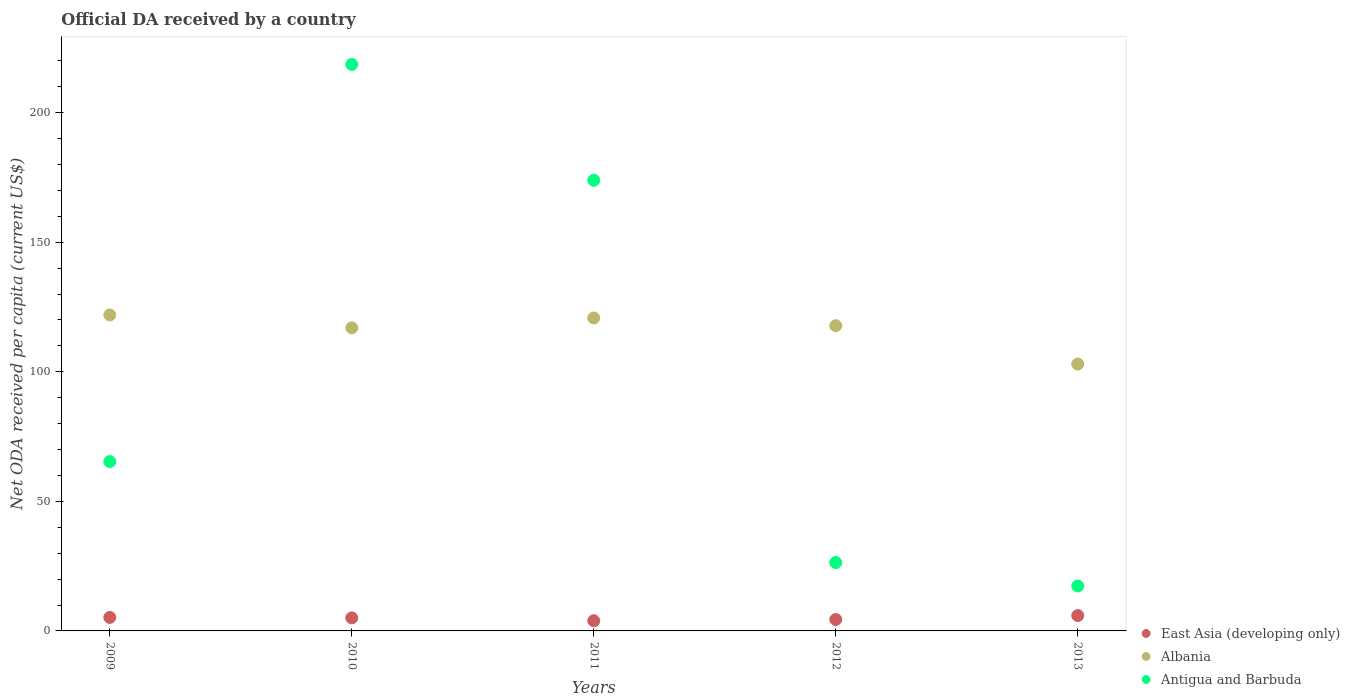Is the number of dotlines equal to the number of legend labels?
Offer a terse response. Yes. What is the ODA received in in East Asia (developing only) in 2013?
Your answer should be very brief. 5.92. Across all years, what is the maximum ODA received in in Antigua and Barbuda?
Ensure brevity in your answer.  218.61. Across all years, what is the minimum ODA received in in Albania?
Give a very brief answer. 102.98. What is the total ODA received in in East Asia (developing only) in the graph?
Your response must be concise. 24.51. What is the difference between the ODA received in in Antigua and Barbuda in 2011 and that in 2012?
Your answer should be compact. 147.52. What is the difference between the ODA received in in Antigua and Barbuda in 2013 and the ODA received in in East Asia (developing only) in 2012?
Ensure brevity in your answer.  12.92. What is the average ODA received in in Antigua and Barbuda per year?
Offer a terse response. 100.32. In the year 2012, what is the difference between the ODA received in in East Asia (developing only) and ODA received in in Antigua and Barbuda?
Your answer should be compact. -21.97. In how many years, is the ODA received in in East Asia (developing only) greater than 120 US$?
Your answer should be compact. 0. What is the ratio of the ODA received in in Antigua and Barbuda in 2010 to that in 2013?
Make the answer very short. 12.61. What is the difference between the highest and the second highest ODA received in in Albania?
Provide a short and direct response. 1.18. What is the difference between the highest and the lowest ODA received in in Antigua and Barbuda?
Your response must be concise. 201.27. In how many years, is the ODA received in in East Asia (developing only) greater than the average ODA received in in East Asia (developing only) taken over all years?
Your answer should be compact. 3. Is it the case that in every year, the sum of the ODA received in in Antigua and Barbuda and ODA received in in East Asia (developing only)  is greater than the ODA received in in Albania?
Offer a very short reply. No. Is the ODA received in in Albania strictly less than the ODA received in in Antigua and Barbuda over the years?
Provide a short and direct response. No. How many years are there in the graph?
Provide a short and direct response. 5. Are the values on the major ticks of Y-axis written in scientific E-notation?
Give a very brief answer. No. Does the graph contain any zero values?
Give a very brief answer. No. Does the graph contain grids?
Make the answer very short. No. What is the title of the graph?
Your response must be concise. Official DA received by a country. Does "Liberia" appear as one of the legend labels in the graph?
Keep it short and to the point. No. What is the label or title of the X-axis?
Keep it short and to the point. Years. What is the label or title of the Y-axis?
Offer a very short reply. Net ODA received per capita (current US$). What is the Net ODA received per capita (current US$) in East Asia (developing only) in 2009?
Ensure brevity in your answer.  5.21. What is the Net ODA received per capita (current US$) of Albania in 2009?
Offer a terse response. 121.93. What is the Net ODA received per capita (current US$) in Antigua and Barbuda in 2009?
Your answer should be very brief. 65.35. What is the Net ODA received per capita (current US$) of East Asia (developing only) in 2010?
Keep it short and to the point. 5.03. What is the Net ODA received per capita (current US$) of Albania in 2010?
Keep it short and to the point. 116.96. What is the Net ODA received per capita (current US$) in Antigua and Barbuda in 2010?
Your answer should be compact. 218.61. What is the Net ODA received per capita (current US$) of East Asia (developing only) in 2011?
Your answer should be very brief. 3.94. What is the Net ODA received per capita (current US$) in Albania in 2011?
Offer a terse response. 120.75. What is the Net ODA received per capita (current US$) in Antigua and Barbuda in 2011?
Your answer should be compact. 173.9. What is the Net ODA received per capita (current US$) in East Asia (developing only) in 2012?
Provide a succinct answer. 4.42. What is the Net ODA received per capita (current US$) in Albania in 2012?
Provide a short and direct response. 117.78. What is the Net ODA received per capita (current US$) in Antigua and Barbuda in 2012?
Make the answer very short. 26.38. What is the Net ODA received per capita (current US$) in East Asia (developing only) in 2013?
Keep it short and to the point. 5.92. What is the Net ODA received per capita (current US$) of Albania in 2013?
Make the answer very short. 102.98. What is the Net ODA received per capita (current US$) in Antigua and Barbuda in 2013?
Provide a short and direct response. 17.34. Across all years, what is the maximum Net ODA received per capita (current US$) in East Asia (developing only)?
Give a very brief answer. 5.92. Across all years, what is the maximum Net ODA received per capita (current US$) of Albania?
Your answer should be very brief. 121.93. Across all years, what is the maximum Net ODA received per capita (current US$) of Antigua and Barbuda?
Make the answer very short. 218.61. Across all years, what is the minimum Net ODA received per capita (current US$) of East Asia (developing only)?
Ensure brevity in your answer.  3.94. Across all years, what is the minimum Net ODA received per capita (current US$) of Albania?
Give a very brief answer. 102.98. Across all years, what is the minimum Net ODA received per capita (current US$) in Antigua and Barbuda?
Provide a succinct answer. 17.34. What is the total Net ODA received per capita (current US$) of East Asia (developing only) in the graph?
Ensure brevity in your answer.  24.51. What is the total Net ODA received per capita (current US$) in Albania in the graph?
Your response must be concise. 580.4. What is the total Net ODA received per capita (current US$) of Antigua and Barbuda in the graph?
Make the answer very short. 501.59. What is the difference between the Net ODA received per capita (current US$) in East Asia (developing only) in 2009 and that in 2010?
Your answer should be compact. 0.18. What is the difference between the Net ODA received per capita (current US$) in Albania in 2009 and that in 2010?
Provide a succinct answer. 4.97. What is the difference between the Net ODA received per capita (current US$) of Antigua and Barbuda in 2009 and that in 2010?
Your answer should be very brief. -153.26. What is the difference between the Net ODA received per capita (current US$) of East Asia (developing only) in 2009 and that in 2011?
Offer a terse response. 1.28. What is the difference between the Net ODA received per capita (current US$) in Albania in 2009 and that in 2011?
Ensure brevity in your answer.  1.18. What is the difference between the Net ODA received per capita (current US$) in Antigua and Barbuda in 2009 and that in 2011?
Your response must be concise. -108.55. What is the difference between the Net ODA received per capita (current US$) in East Asia (developing only) in 2009 and that in 2012?
Your answer should be compact. 0.8. What is the difference between the Net ODA received per capita (current US$) of Albania in 2009 and that in 2012?
Your response must be concise. 4.15. What is the difference between the Net ODA received per capita (current US$) in Antigua and Barbuda in 2009 and that in 2012?
Your answer should be very brief. 38.97. What is the difference between the Net ODA received per capita (current US$) in East Asia (developing only) in 2009 and that in 2013?
Keep it short and to the point. -0.71. What is the difference between the Net ODA received per capita (current US$) of Albania in 2009 and that in 2013?
Your answer should be compact. 18.95. What is the difference between the Net ODA received per capita (current US$) in Antigua and Barbuda in 2009 and that in 2013?
Your answer should be compact. 48.02. What is the difference between the Net ODA received per capita (current US$) in East Asia (developing only) in 2010 and that in 2011?
Ensure brevity in your answer.  1.09. What is the difference between the Net ODA received per capita (current US$) of Albania in 2010 and that in 2011?
Keep it short and to the point. -3.79. What is the difference between the Net ODA received per capita (current US$) of Antigua and Barbuda in 2010 and that in 2011?
Your answer should be very brief. 44.71. What is the difference between the Net ODA received per capita (current US$) of East Asia (developing only) in 2010 and that in 2012?
Offer a very short reply. 0.61. What is the difference between the Net ODA received per capita (current US$) of Albania in 2010 and that in 2012?
Ensure brevity in your answer.  -0.82. What is the difference between the Net ODA received per capita (current US$) of Antigua and Barbuda in 2010 and that in 2012?
Your response must be concise. 192.23. What is the difference between the Net ODA received per capita (current US$) of East Asia (developing only) in 2010 and that in 2013?
Ensure brevity in your answer.  -0.89. What is the difference between the Net ODA received per capita (current US$) of Albania in 2010 and that in 2013?
Make the answer very short. 13.97. What is the difference between the Net ODA received per capita (current US$) of Antigua and Barbuda in 2010 and that in 2013?
Give a very brief answer. 201.27. What is the difference between the Net ODA received per capita (current US$) of East Asia (developing only) in 2011 and that in 2012?
Offer a terse response. -0.48. What is the difference between the Net ODA received per capita (current US$) in Albania in 2011 and that in 2012?
Make the answer very short. 2.97. What is the difference between the Net ODA received per capita (current US$) of Antigua and Barbuda in 2011 and that in 2012?
Keep it short and to the point. 147.52. What is the difference between the Net ODA received per capita (current US$) in East Asia (developing only) in 2011 and that in 2013?
Offer a terse response. -1.98. What is the difference between the Net ODA received per capita (current US$) of Albania in 2011 and that in 2013?
Give a very brief answer. 17.77. What is the difference between the Net ODA received per capita (current US$) in Antigua and Barbuda in 2011 and that in 2013?
Keep it short and to the point. 156.57. What is the difference between the Net ODA received per capita (current US$) in East Asia (developing only) in 2012 and that in 2013?
Ensure brevity in your answer.  -1.5. What is the difference between the Net ODA received per capita (current US$) in Albania in 2012 and that in 2013?
Give a very brief answer. 14.8. What is the difference between the Net ODA received per capita (current US$) of Antigua and Barbuda in 2012 and that in 2013?
Your answer should be very brief. 9.05. What is the difference between the Net ODA received per capita (current US$) of East Asia (developing only) in 2009 and the Net ODA received per capita (current US$) of Albania in 2010?
Offer a very short reply. -111.75. What is the difference between the Net ODA received per capita (current US$) in East Asia (developing only) in 2009 and the Net ODA received per capita (current US$) in Antigua and Barbuda in 2010?
Provide a short and direct response. -213.4. What is the difference between the Net ODA received per capita (current US$) of Albania in 2009 and the Net ODA received per capita (current US$) of Antigua and Barbuda in 2010?
Your response must be concise. -96.68. What is the difference between the Net ODA received per capita (current US$) of East Asia (developing only) in 2009 and the Net ODA received per capita (current US$) of Albania in 2011?
Offer a terse response. -115.54. What is the difference between the Net ODA received per capita (current US$) of East Asia (developing only) in 2009 and the Net ODA received per capita (current US$) of Antigua and Barbuda in 2011?
Offer a terse response. -168.69. What is the difference between the Net ODA received per capita (current US$) in Albania in 2009 and the Net ODA received per capita (current US$) in Antigua and Barbuda in 2011?
Your response must be concise. -51.97. What is the difference between the Net ODA received per capita (current US$) in East Asia (developing only) in 2009 and the Net ODA received per capita (current US$) in Albania in 2012?
Make the answer very short. -112.57. What is the difference between the Net ODA received per capita (current US$) of East Asia (developing only) in 2009 and the Net ODA received per capita (current US$) of Antigua and Barbuda in 2012?
Offer a very short reply. -21.17. What is the difference between the Net ODA received per capita (current US$) of Albania in 2009 and the Net ODA received per capita (current US$) of Antigua and Barbuda in 2012?
Your response must be concise. 95.55. What is the difference between the Net ODA received per capita (current US$) of East Asia (developing only) in 2009 and the Net ODA received per capita (current US$) of Albania in 2013?
Keep it short and to the point. -97.77. What is the difference between the Net ODA received per capita (current US$) of East Asia (developing only) in 2009 and the Net ODA received per capita (current US$) of Antigua and Barbuda in 2013?
Keep it short and to the point. -12.12. What is the difference between the Net ODA received per capita (current US$) in Albania in 2009 and the Net ODA received per capita (current US$) in Antigua and Barbuda in 2013?
Your answer should be compact. 104.6. What is the difference between the Net ODA received per capita (current US$) in East Asia (developing only) in 2010 and the Net ODA received per capita (current US$) in Albania in 2011?
Provide a short and direct response. -115.72. What is the difference between the Net ODA received per capita (current US$) in East Asia (developing only) in 2010 and the Net ODA received per capita (current US$) in Antigua and Barbuda in 2011?
Your answer should be compact. -168.88. What is the difference between the Net ODA received per capita (current US$) of Albania in 2010 and the Net ODA received per capita (current US$) of Antigua and Barbuda in 2011?
Your answer should be very brief. -56.95. What is the difference between the Net ODA received per capita (current US$) in East Asia (developing only) in 2010 and the Net ODA received per capita (current US$) in Albania in 2012?
Ensure brevity in your answer.  -112.75. What is the difference between the Net ODA received per capita (current US$) of East Asia (developing only) in 2010 and the Net ODA received per capita (current US$) of Antigua and Barbuda in 2012?
Give a very brief answer. -21.36. What is the difference between the Net ODA received per capita (current US$) in Albania in 2010 and the Net ODA received per capita (current US$) in Antigua and Barbuda in 2012?
Your answer should be very brief. 90.57. What is the difference between the Net ODA received per capita (current US$) of East Asia (developing only) in 2010 and the Net ODA received per capita (current US$) of Albania in 2013?
Offer a terse response. -97.96. What is the difference between the Net ODA received per capita (current US$) in East Asia (developing only) in 2010 and the Net ODA received per capita (current US$) in Antigua and Barbuda in 2013?
Your response must be concise. -12.31. What is the difference between the Net ODA received per capita (current US$) of Albania in 2010 and the Net ODA received per capita (current US$) of Antigua and Barbuda in 2013?
Provide a succinct answer. 99.62. What is the difference between the Net ODA received per capita (current US$) in East Asia (developing only) in 2011 and the Net ODA received per capita (current US$) in Albania in 2012?
Keep it short and to the point. -113.84. What is the difference between the Net ODA received per capita (current US$) of East Asia (developing only) in 2011 and the Net ODA received per capita (current US$) of Antigua and Barbuda in 2012?
Provide a succinct answer. -22.45. What is the difference between the Net ODA received per capita (current US$) of Albania in 2011 and the Net ODA received per capita (current US$) of Antigua and Barbuda in 2012?
Give a very brief answer. 94.37. What is the difference between the Net ODA received per capita (current US$) in East Asia (developing only) in 2011 and the Net ODA received per capita (current US$) in Albania in 2013?
Provide a short and direct response. -99.05. What is the difference between the Net ODA received per capita (current US$) of East Asia (developing only) in 2011 and the Net ODA received per capita (current US$) of Antigua and Barbuda in 2013?
Your answer should be compact. -13.4. What is the difference between the Net ODA received per capita (current US$) of Albania in 2011 and the Net ODA received per capita (current US$) of Antigua and Barbuda in 2013?
Make the answer very short. 103.41. What is the difference between the Net ODA received per capita (current US$) of East Asia (developing only) in 2012 and the Net ODA received per capita (current US$) of Albania in 2013?
Your answer should be very brief. -98.57. What is the difference between the Net ODA received per capita (current US$) in East Asia (developing only) in 2012 and the Net ODA received per capita (current US$) in Antigua and Barbuda in 2013?
Give a very brief answer. -12.92. What is the difference between the Net ODA received per capita (current US$) in Albania in 2012 and the Net ODA received per capita (current US$) in Antigua and Barbuda in 2013?
Your answer should be very brief. 100.44. What is the average Net ODA received per capita (current US$) of East Asia (developing only) per year?
Your response must be concise. 4.9. What is the average Net ODA received per capita (current US$) in Albania per year?
Keep it short and to the point. 116.08. What is the average Net ODA received per capita (current US$) of Antigua and Barbuda per year?
Ensure brevity in your answer.  100.32. In the year 2009, what is the difference between the Net ODA received per capita (current US$) in East Asia (developing only) and Net ODA received per capita (current US$) in Albania?
Give a very brief answer. -116.72. In the year 2009, what is the difference between the Net ODA received per capita (current US$) in East Asia (developing only) and Net ODA received per capita (current US$) in Antigua and Barbuda?
Give a very brief answer. -60.14. In the year 2009, what is the difference between the Net ODA received per capita (current US$) in Albania and Net ODA received per capita (current US$) in Antigua and Barbuda?
Your answer should be very brief. 56.58. In the year 2010, what is the difference between the Net ODA received per capita (current US$) of East Asia (developing only) and Net ODA received per capita (current US$) of Albania?
Your answer should be very brief. -111.93. In the year 2010, what is the difference between the Net ODA received per capita (current US$) in East Asia (developing only) and Net ODA received per capita (current US$) in Antigua and Barbuda?
Your answer should be compact. -213.58. In the year 2010, what is the difference between the Net ODA received per capita (current US$) of Albania and Net ODA received per capita (current US$) of Antigua and Barbuda?
Offer a terse response. -101.65. In the year 2011, what is the difference between the Net ODA received per capita (current US$) of East Asia (developing only) and Net ODA received per capita (current US$) of Albania?
Offer a very short reply. -116.81. In the year 2011, what is the difference between the Net ODA received per capita (current US$) of East Asia (developing only) and Net ODA received per capita (current US$) of Antigua and Barbuda?
Give a very brief answer. -169.97. In the year 2011, what is the difference between the Net ODA received per capita (current US$) in Albania and Net ODA received per capita (current US$) in Antigua and Barbuda?
Provide a succinct answer. -53.15. In the year 2012, what is the difference between the Net ODA received per capita (current US$) of East Asia (developing only) and Net ODA received per capita (current US$) of Albania?
Ensure brevity in your answer.  -113.36. In the year 2012, what is the difference between the Net ODA received per capita (current US$) in East Asia (developing only) and Net ODA received per capita (current US$) in Antigua and Barbuda?
Your answer should be very brief. -21.97. In the year 2012, what is the difference between the Net ODA received per capita (current US$) in Albania and Net ODA received per capita (current US$) in Antigua and Barbuda?
Your response must be concise. 91.4. In the year 2013, what is the difference between the Net ODA received per capita (current US$) of East Asia (developing only) and Net ODA received per capita (current US$) of Albania?
Offer a terse response. -97.06. In the year 2013, what is the difference between the Net ODA received per capita (current US$) in East Asia (developing only) and Net ODA received per capita (current US$) in Antigua and Barbuda?
Provide a short and direct response. -11.42. In the year 2013, what is the difference between the Net ODA received per capita (current US$) of Albania and Net ODA received per capita (current US$) of Antigua and Barbuda?
Make the answer very short. 85.65. What is the ratio of the Net ODA received per capita (current US$) of East Asia (developing only) in 2009 to that in 2010?
Make the answer very short. 1.04. What is the ratio of the Net ODA received per capita (current US$) of Albania in 2009 to that in 2010?
Make the answer very short. 1.04. What is the ratio of the Net ODA received per capita (current US$) of Antigua and Barbuda in 2009 to that in 2010?
Ensure brevity in your answer.  0.3. What is the ratio of the Net ODA received per capita (current US$) of East Asia (developing only) in 2009 to that in 2011?
Provide a succinct answer. 1.32. What is the ratio of the Net ODA received per capita (current US$) in Albania in 2009 to that in 2011?
Provide a succinct answer. 1.01. What is the ratio of the Net ODA received per capita (current US$) of Antigua and Barbuda in 2009 to that in 2011?
Give a very brief answer. 0.38. What is the ratio of the Net ODA received per capita (current US$) of East Asia (developing only) in 2009 to that in 2012?
Your answer should be compact. 1.18. What is the ratio of the Net ODA received per capita (current US$) in Albania in 2009 to that in 2012?
Ensure brevity in your answer.  1.04. What is the ratio of the Net ODA received per capita (current US$) of Antigua and Barbuda in 2009 to that in 2012?
Offer a very short reply. 2.48. What is the ratio of the Net ODA received per capita (current US$) in East Asia (developing only) in 2009 to that in 2013?
Your answer should be very brief. 0.88. What is the ratio of the Net ODA received per capita (current US$) in Albania in 2009 to that in 2013?
Keep it short and to the point. 1.18. What is the ratio of the Net ODA received per capita (current US$) in Antigua and Barbuda in 2009 to that in 2013?
Your answer should be very brief. 3.77. What is the ratio of the Net ODA received per capita (current US$) of East Asia (developing only) in 2010 to that in 2011?
Provide a short and direct response. 1.28. What is the ratio of the Net ODA received per capita (current US$) of Albania in 2010 to that in 2011?
Keep it short and to the point. 0.97. What is the ratio of the Net ODA received per capita (current US$) of Antigua and Barbuda in 2010 to that in 2011?
Your answer should be compact. 1.26. What is the ratio of the Net ODA received per capita (current US$) in East Asia (developing only) in 2010 to that in 2012?
Offer a very short reply. 1.14. What is the ratio of the Net ODA received per capita (current US$) of Albania in 2010 to that in 2012?
Your answer should be compact. 0.99. What is the ratio of the Net ODA received per capita (current US$) of Antigua and Barbuda in 2010 to that in 2012?
Provide a short and direct response. 8.29. What is the ratio of the Net ODA received per capita (current US$) in East Asia (developing only) in 2010 to that in 2013?
Make the answer very short. 0.85. What is the ratio of the Net ODA received per capita (current US$) of Albania in 2010 to that in 2013?
Provide a short and direct response. 1.14. What is the ratio of the Net ODA received per capita (current US$) in Antigua and Barbuda in 2010 to that in 2013?
Your response must be concise. 12.61. What is the ratio of the Net ODA received per capita (current US$) in East Asia (developing only) in 2011 to that in 2012?
Your answer should be compact. 0.89. What is the ratio of the Net ODA received per capita (current US$) in Albania in 2011 to that in 2012?
Keep it short and to the point. 1.03. What is the ratio of the Net ODA received per capita (current US$) of Antigua and Barbuda in 2011 to that in 2012?
Offer a terse response. 6.59. What is the ratio of the Net ODA received per capita (current US$) in East Asia (developing only) in 2011 to that in 2013?
Your answer should be compact. 0.66. What is the ratio of the Net ODA received per capita (current US$) of Albania in 2011 to that in 2013?
Your response must be concise. 1.17. What is the ratio of the Net ODA received per capita (current US$) in Antigua and Barbuda in 2011 to that in 2013?
Offer a terse response. 10.03. What is the ratio of the Net ODA received per capita (current US$) of East Asia (developing only) in 2012 to that in 2013?
Offer a very short reply. 0.75. What is the ratio of the Net ODA received per capita (current US$) of Albania in 2012 to that in 2013?
Your answer should be very brief. 1.14. What is the ratio of the Net ODA received per capita (current US$) in Antigua and Barbuda in 2012 to that in 2013?
Offer a very short reply. 1.52. What is the difference between the highest and the second highest Net ODA received per capita (current US$) of East Asia (developing only)?
Your response must be concise. 0.71. What is the difference between the highest and the second highest Net ODA received per capita (current US$) of Albania?
Your response must be concise. 1.18. What is the difference between the highest and the second highest Net ODA received per capita (current US$) of Antigua and Barbuda?
Ensure brevity in your answer.  44.71. What is the difference between the highest and the lowest Net ODA received per capita (current US$) in East Asia (developing only)?
Offer a very short reply. 1.98. What is the difference between the highest and the lowest Net ODA received per capita (current US$) of Albania?
Your answer should be compact. 18.95. What is the difference between the highest and the lowest Net ODA received per capita (current US$) in Antigua and Barbuda?
Ensure brevity in your answer.  201.27. 